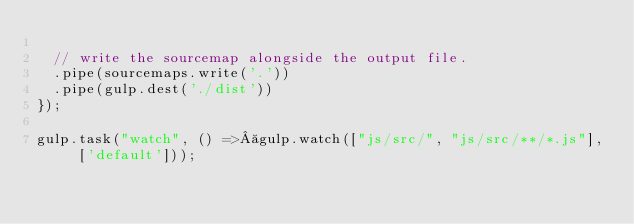Convert code to text. <code><loc_0><loc_0><loc_500><loc_500><_JavaScript_>
  // write the sourcemap alongside the output file.
  .pipe(sourcemaps.write('.'))
  .pipe(gulp.dest('./dist'))
});

gulp.task("watch", () => gulp.watch(["js/src/", "js/src/**/*.js"], ['default']));


</code> 